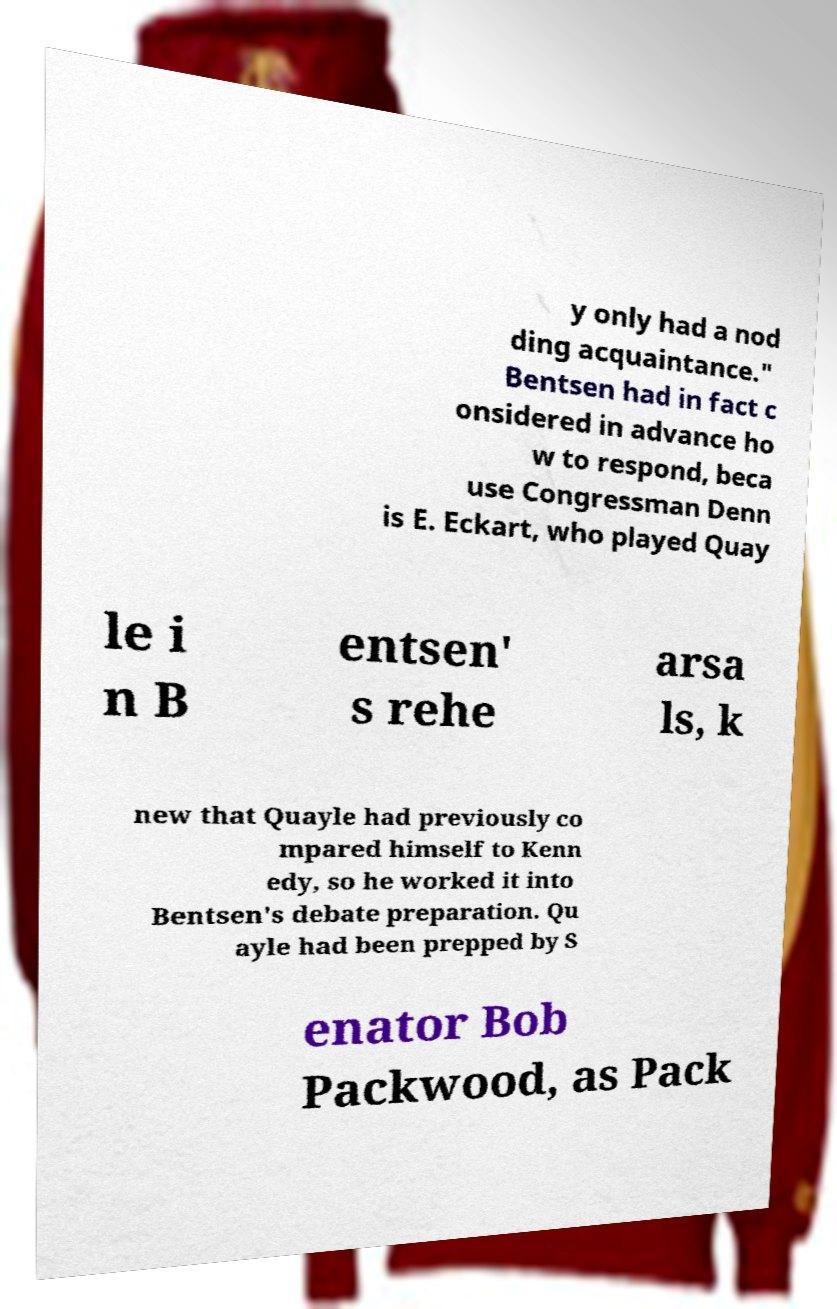Can you accurately transcribe the text from the provided image for me? y only had a nod ding acquaintance." Bentsen had in fact c onsidered in advance ho w to respond, beca use Congressman Denn is E. Eckart, who played Quay le i n B entsen' s rehe arsa ls, k new that Quayle had previously co mpared himself to Kenn edy, so he worked it into Bentsen's debate preparation. Qu ayle had been prepped by S enator Bob Packwood, as Pack 